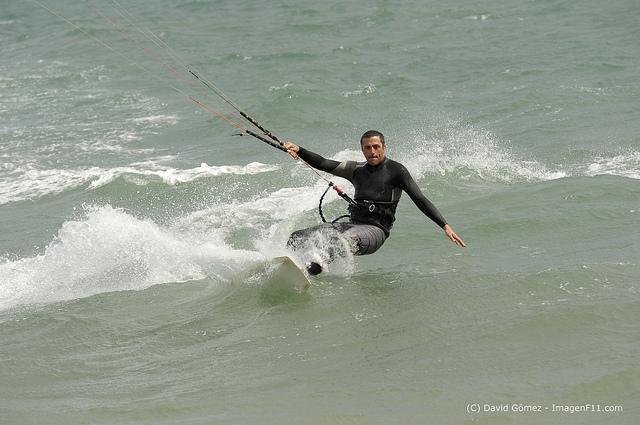How many chairs are in this picture?
Give a very brief answer. 0. 